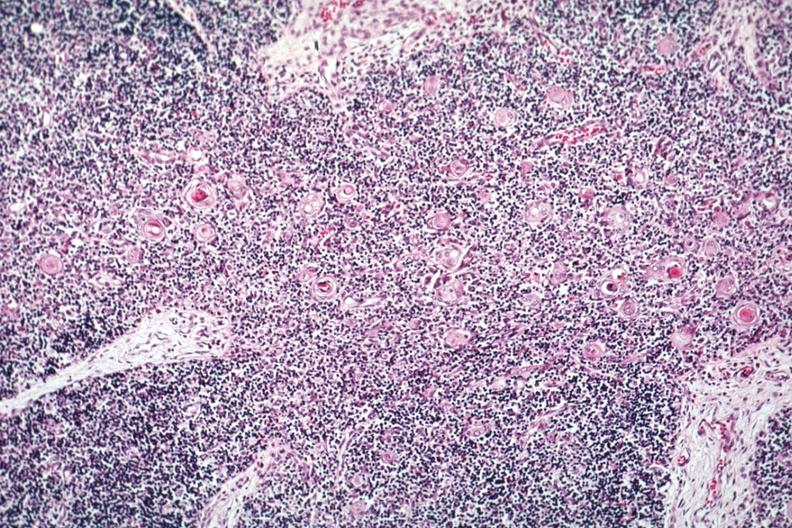what is present?
Answer the question using a single word or phrase. Thymus 